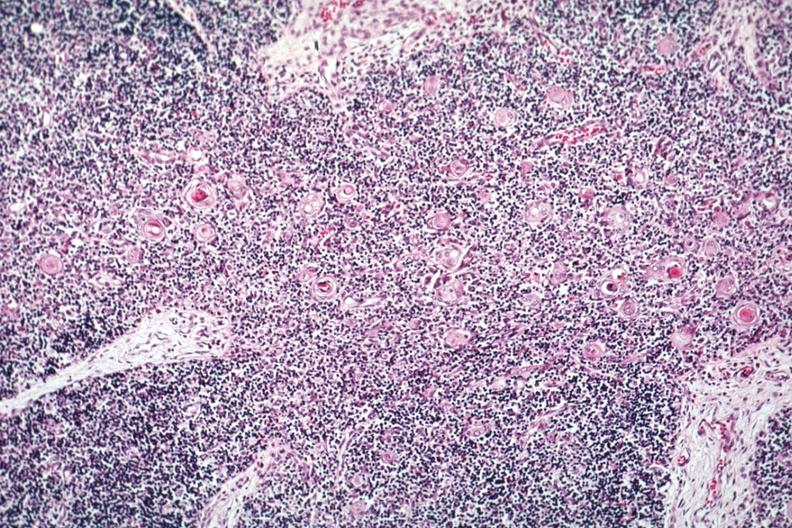what is present?
Answer the question using a single word or phrase. Thymus 